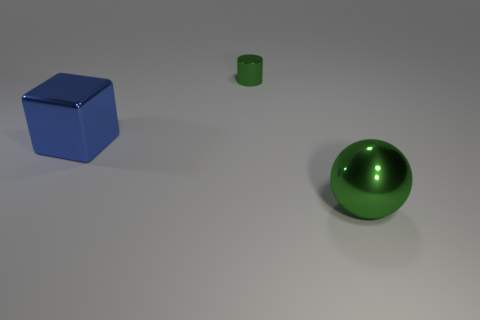Do the big thing right of the blue thing and the large metallic object that is left of the tiny green object have the same shape?
Give a very brief answer. No. What number of objects are either cylinders or big green shiny spheres?
Your answer should be very brief. 2. Is the number of big blue cubes in front of the small metal cylinder greater than the number of large blue shiny cubes?
Keep it short and to the point. No. Does the tiny green object have the same material as the big cube?
Offer a very short reply. Yes. How many things are green things to the right of the small cylinder or large metal things on the right side of the metallic block?
Give a very brief answer. 1. How many other metal blocks have the same color as the block?
Your answer should be compact. 0. Does the tiny thing have the same color as the large shiny block?
Your answer should be compact. No. How many things are metallic things to the right of the blue object or blue objects?
Your answer should be compact. 3. The metal thing that is on the left side of the green object that is behind the large metallic object on the right side of the small cylinder is what color?
Make the answer very short. Blue. The other small thing that is the same material as the blue object is what color?
Your answer should be compact. Green. 